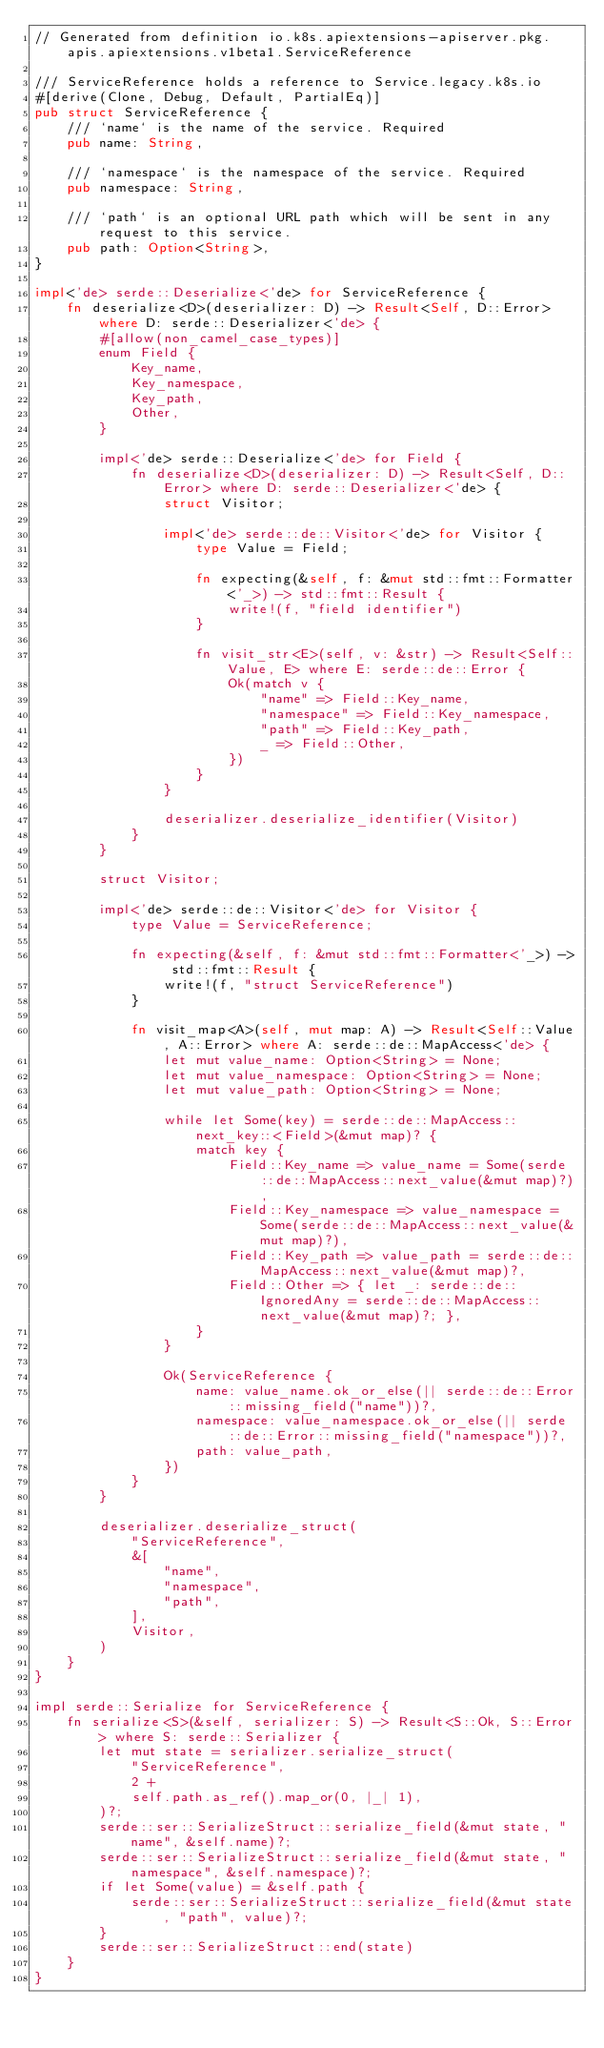Convert code to text. <code><loc_0><loc_0><loc_500><loc_500><_Rust_>// Generated from definition io.k8s.apiextensions-apiserver.pkg.apis.apiextensions.v1beta1.ServiceReference

/// ServiceReference holds a reference to Service.legacy.k8s.io
#[derive(Clone, Debug, Default, PartialEq)]
pub struct ServiceReference {
    /// `name` is the name of the service. Required
    pub name: String,

    /// `namespace` is the namespace of the service. Required
    pub namespace: String,

    /// `path` is an optional URL path which will be sent in any request to this service.
    pub path: Option<String>,
}

impl<'de> serde::Deserialize<'de> for ServiceReference {
    fn deserialize<D>(deserializer: D) -> Result<Self, D::Error> where D: serde::Deserializer<'de> {
        #[allow(non_camel_case_types)]
        enum Field {
            Key_name,
            Key_namespace,
            Key_path,
            Other,
        }

        impl<'de> serde::Deserialize<'de> for Field {
            fn deserialize<D>(deserializer: D) -> Result<Self, D::Error> where D: serde::Deserializer<'de> {
                struct Visitor;

                impl<'de> serde::de::Visitor<'de> for Visitor {
                    type Value = Field;

                    fn expecting(&self, f: &mut std::fmt::Formatter<'_>) -> std::fmt::Result {
                        write!(f, "field identifier")
                    }

                    fn visit_str<E>(self, v: &str) -> Result<Self::Value, E> where E: serde::de::Error {
                        Ok(match v {
                            "name" => Field::Key_name,
                            "namespace" => Field::Key_namespace,
                            "path" => Field::Key_path,
                            _ => Field::Other,
                        })
                    }
                }

                deserializer.deserialize_identifier(Visitor)
            }
        }

        struct Visitor;

        impl<'de> serde::de::Visitor<'de> for Visitor {
            type Value = ServiceReference;

            fn expecting(&self, f: &mut std::fmt::Formatter<'_>) -> std::fmt::Result {
                write!(f, "struct ServiceReference")
            }

            fn visit_map<A>(self, mut map: A) -> Result<Self::Value, A::Error> where A: serde::de::MapAccess<'de> {
                let mut value_name: Option<String> = None;
                let mut value_namespace: Option<String> = None;
                let mut value_path: Option<String> = None;

                while let Some(key) = serde::de::MapAccess::next_key::<Field>(&mut map)? {
                    match key {
                        Field::Key_name => value_name = Some(serde::de::MapAccess::next_value(&mut map)?),
                        Field::Key_namespace => value_namespace = Some(serde::de::MapAccess::next_value(&mut map)?),
                        Field::Key_path => value_path = serde::de::MapAccess::next_value(&mut map)?,
                        Field::Other => { let _: serde::de::IgnoredAny = serde::de::MapAccess::next_value(&mut map)?; },
                    }
                }

                Ok(ServiceReference {
                    name: value_name.ok_or_else(|| serde::de::Error::missing_field("name"))?,
                    namespace: value_namespace.ok_or_else(|| serde::de::Error::missing_field("namespace"))?,
                    path: value_path,
                })
            }
        }

        deserializer.deserialize_struct(
            "ServiceReference",
            &[
                "name",
                "namespace",
                "path",
            ],
            Visitor,
        )
    }
}

impl serde::Serialize for ServiceReference {
    fn serialize<S>(&self, serializer: S) -> Result<S::Ok, S::Error> where S: serde::Serializer {
        let mut state = serializer.serialize_struct(
            "ServiceReference",
            2 +
            self.path.as_ref().map_or(0, |_| 1),
        )?;
        serde::ser::SerializeStruct::serialize_field(&mut state, "name", &self.name)?;
        serde::ser::SerializeStruct::serialize_field(&mut state, "namespace", &self.namespace)?;
        if let Some(value) = &self.path {
            serde::ser::SerializeStruct::serialize_field(&mut state, "path", value)?;
        }
        serde::ser::SerializeStruct::end(state)
    }
}
</code> 